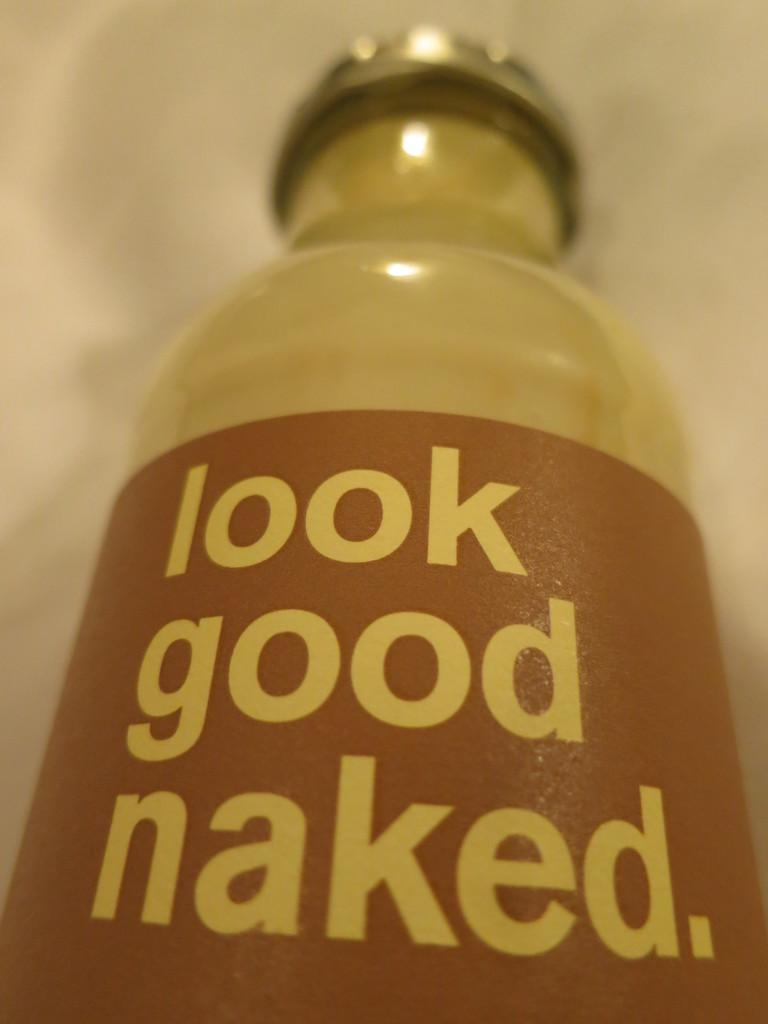<image>
Create a compact narrative representing the image presented. A clear bottle's label says look good naked. 